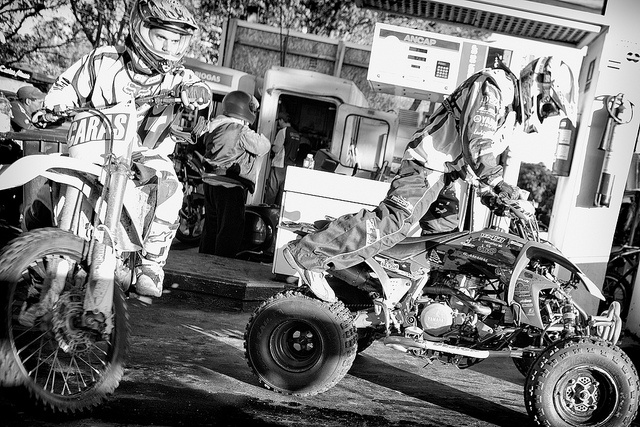Describe the objects in this image and their specific colors. I can see motorcycle in gray, black, darkgray, and lightgray tones, motorcycle in gray, black, lightgray, and darkgray tones, people in gray, darkgray, lightgray, and black tones, people in gray, white, darkgray, and black tones, and people in gray, black, darkgray, and lightgray tones in this image. 